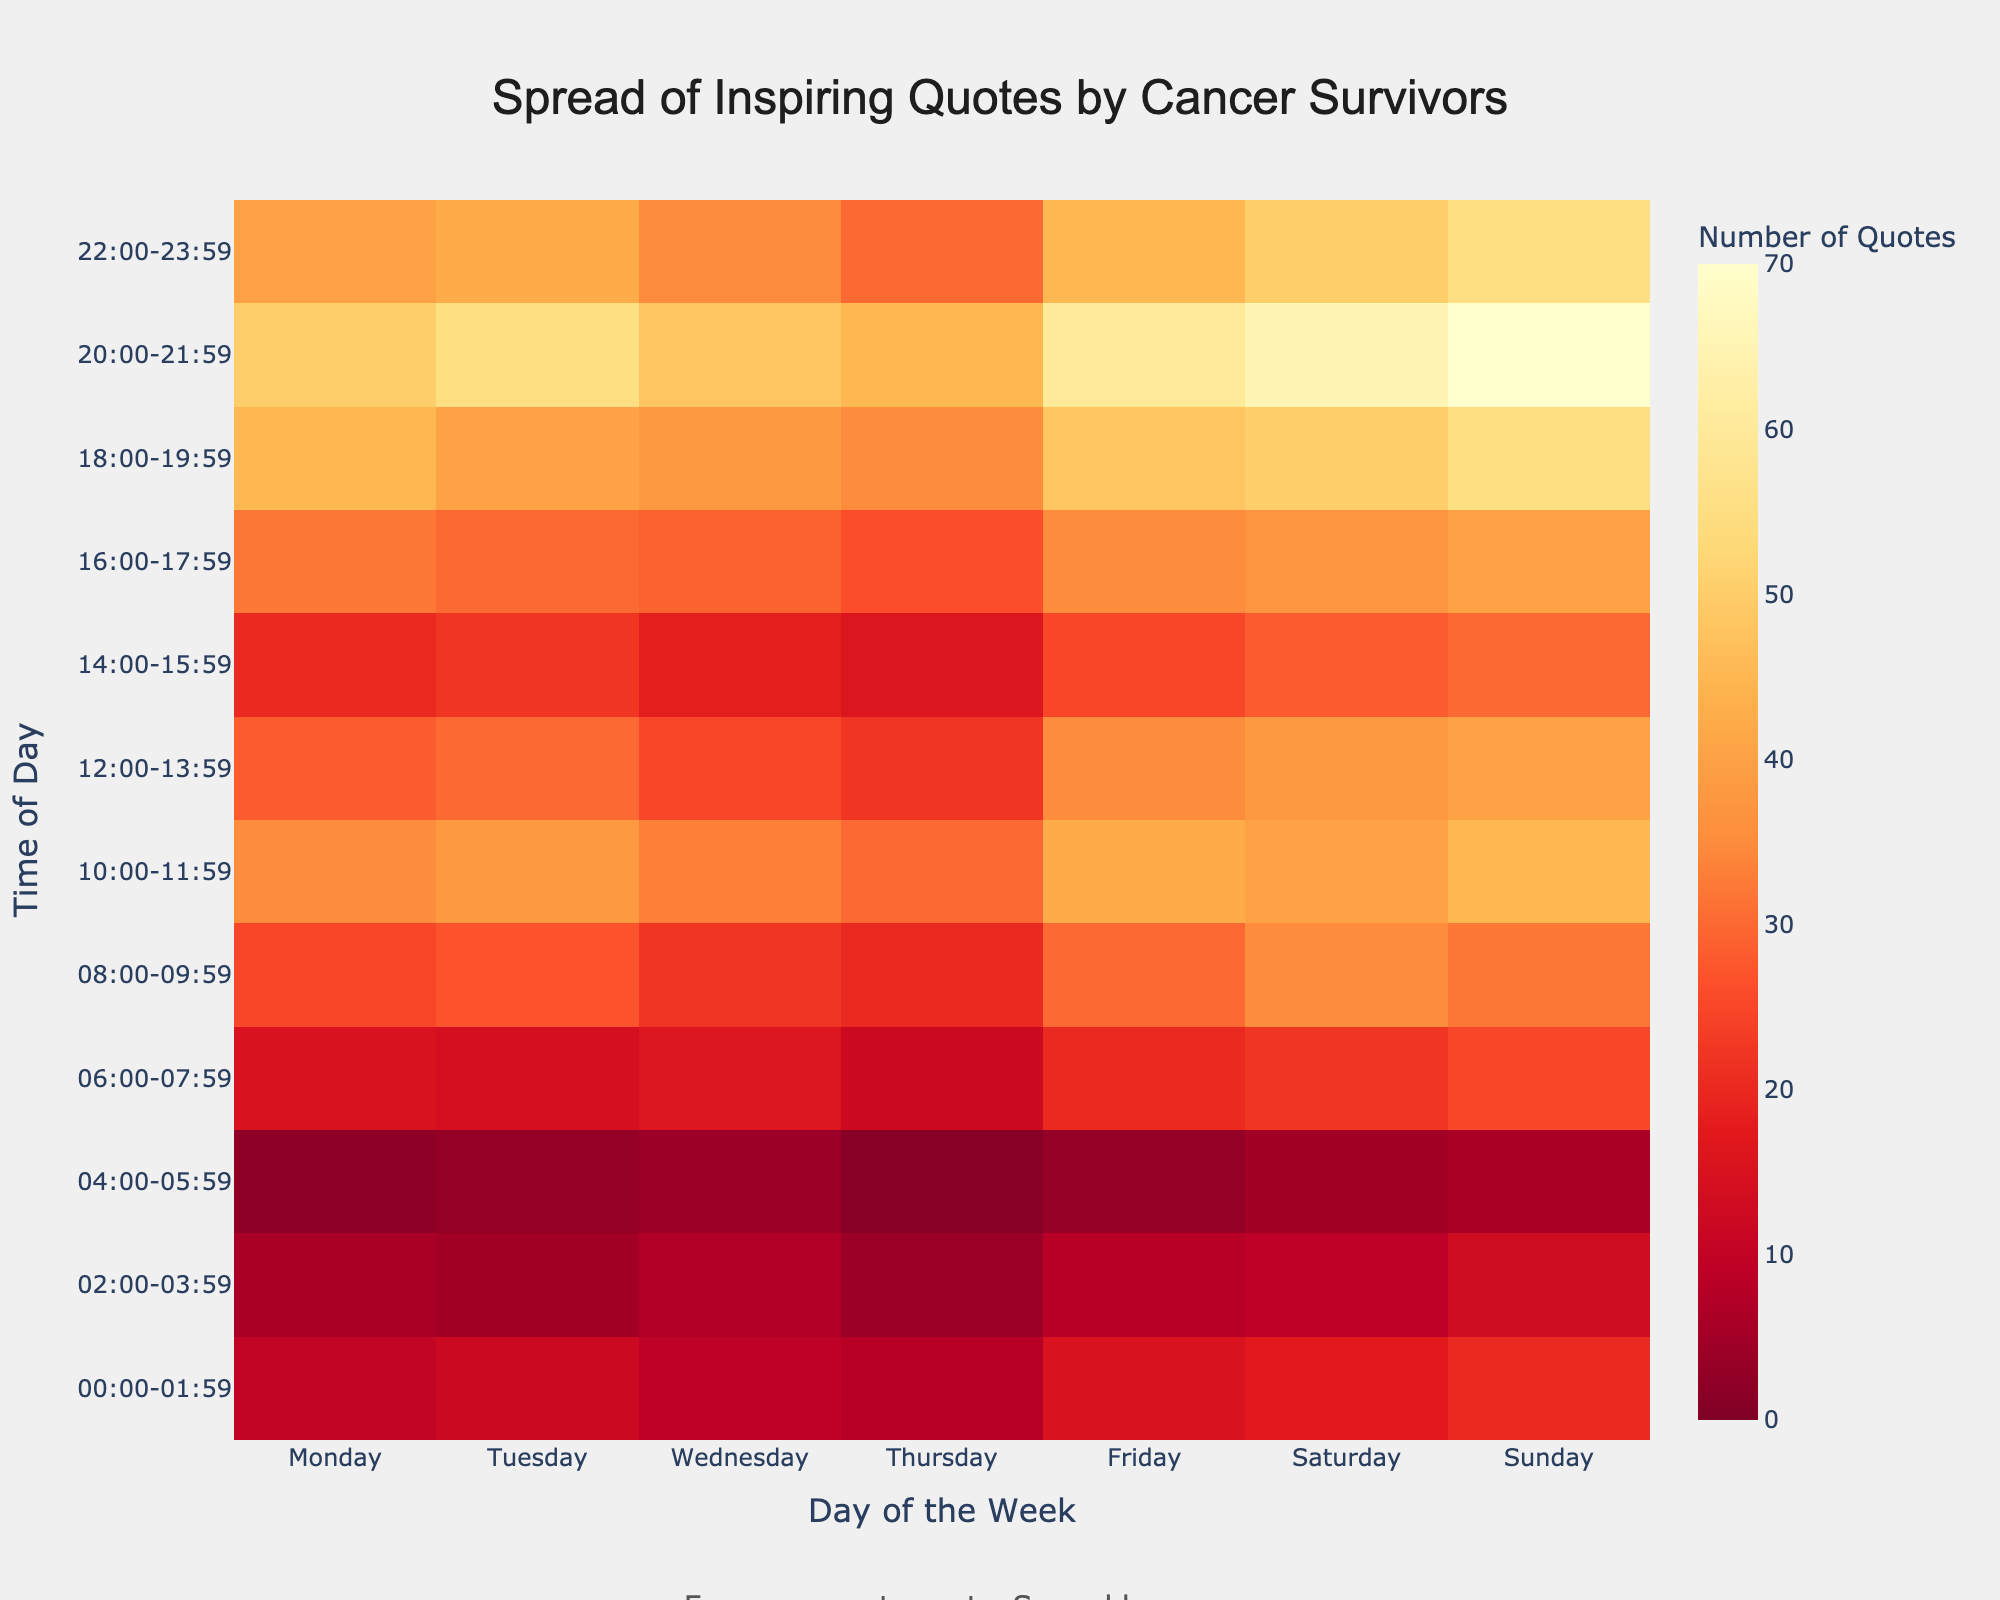Which time slot on Wednesday has the most quotes shared? To determine the time slot with the most quotes on Wednesday, look down the 'Wednesday' column and find the highest number.
Answer: 10:00-11:59 What is the average number of quotes shared on Sunday? Add up the quote counts for all time slots on Sunday: 20 + 13 + 6 + 25 + 32 + 45 + 40 + 30 + 40 + 55 + 70 + 55 = 431. Divide by the number of time slots (12). 431 / 12 = 35.92
Answer: 35.92 Which day has the lowest activity during the 04:00-05:59 time slot? Compare the numbers for all days during the 04:00-05:59 slot. The lowest number is 1, which is on Thursday.
Answer: Thursday How does the number of quotes shared on Friday at 18:00-19:59 compare to Monday at the same time? Compare the counts for Friday and Monday at 18:00-19:59: 48 (Friday) versus 45 (Monday).
Answer: Friday has 3 more quotes than Monday What is the total number of quotes shared across the week at 08:00-09:59? Add the quote counts for each day at 08:00-09:59: 25 + 27 + 22 + 20 + 30 + 35 + 32 = 191
Answer: 191 What is the highest number of quotes shared in a single time slot across the entire week? Scan the heatmap for the highest individual value. The highest number is 70, which occurs on Sunday at 20:00-21:59.
Answer: 70 Which day had the most consistent number of quotes throughout the day? To determine the most consistent day, observe the variation in quotes throughout the day for each day of the week. One way to measure this is to check the day with the least variation. Saturday appears consistent.
Answer: Saturday How does the spread of morning quotes (06:00-11:59) compare between Monday and Thursday? Add the morning quote counts (06:00-11:59) for Monday: 15 + 14 + 16 + 35 + 38 = 118. For Thursday: 12 + 20 + 30 + 33 + 22 = 117.
Answer: Nearly the same, Monday (118) and Thursday (117) During which time slot do we see the highest overall activity across the week? Scan all time slots and sum across all days. The time slot with the highest sum is 20:00-21:59.
Answer: 20:00-21:59 